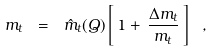Convert formula to latex. <formula><loc_0><loc_0><loc_500><loc_500>m _ { t } \ = \ \hat { m } _ { t } ( Q ) \left [ \, 1 + \, { \frac { \Delta m _ { t } } { m _ { t } } } \, \right ] \ ,</formula> 